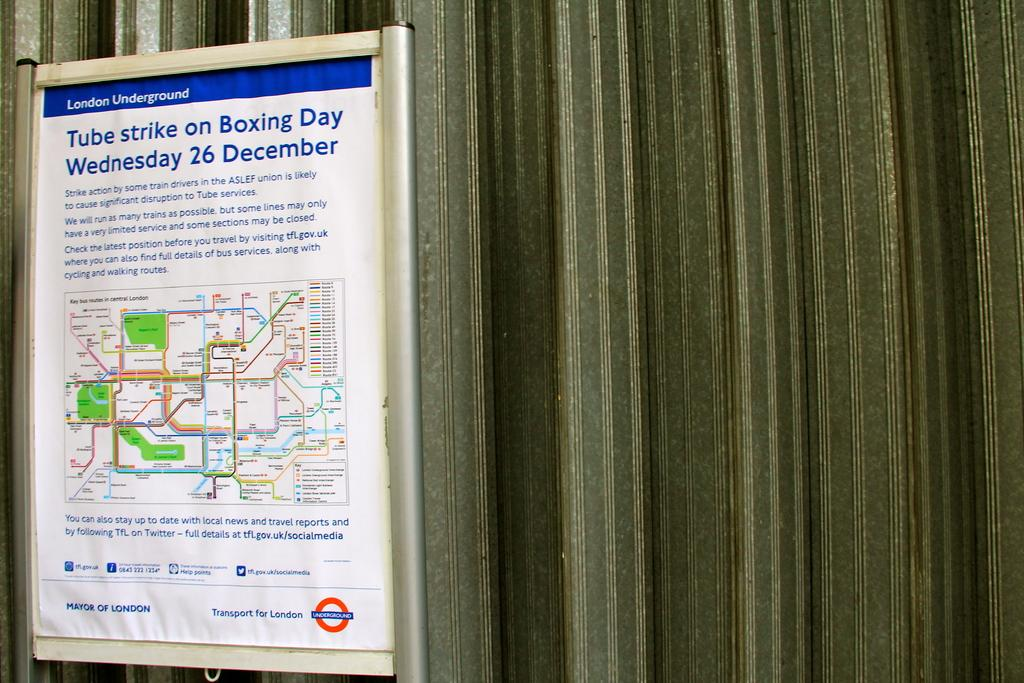<image>
Summarize the visual content of the image. A poster hanging that states that there will be tube strike on December 26 